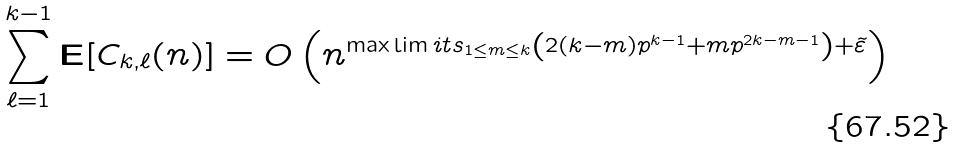<formula> <loc_0><loc_0><loc_500><loc_500>\sum _ { \ell = 1 } ^ { k - 1 } \mathbf E [ C _ { k , \ell } ( n ) ] = O \left ( n ^ { \max \lim i t s _ { 1 \leq m \leq k } \left ( 2 ( k - m ) p ^ { k - 1 } + m p ^ { 2 k - m - 1 } \right ) + \tilde { \varepsilon } } \right )</formula> 